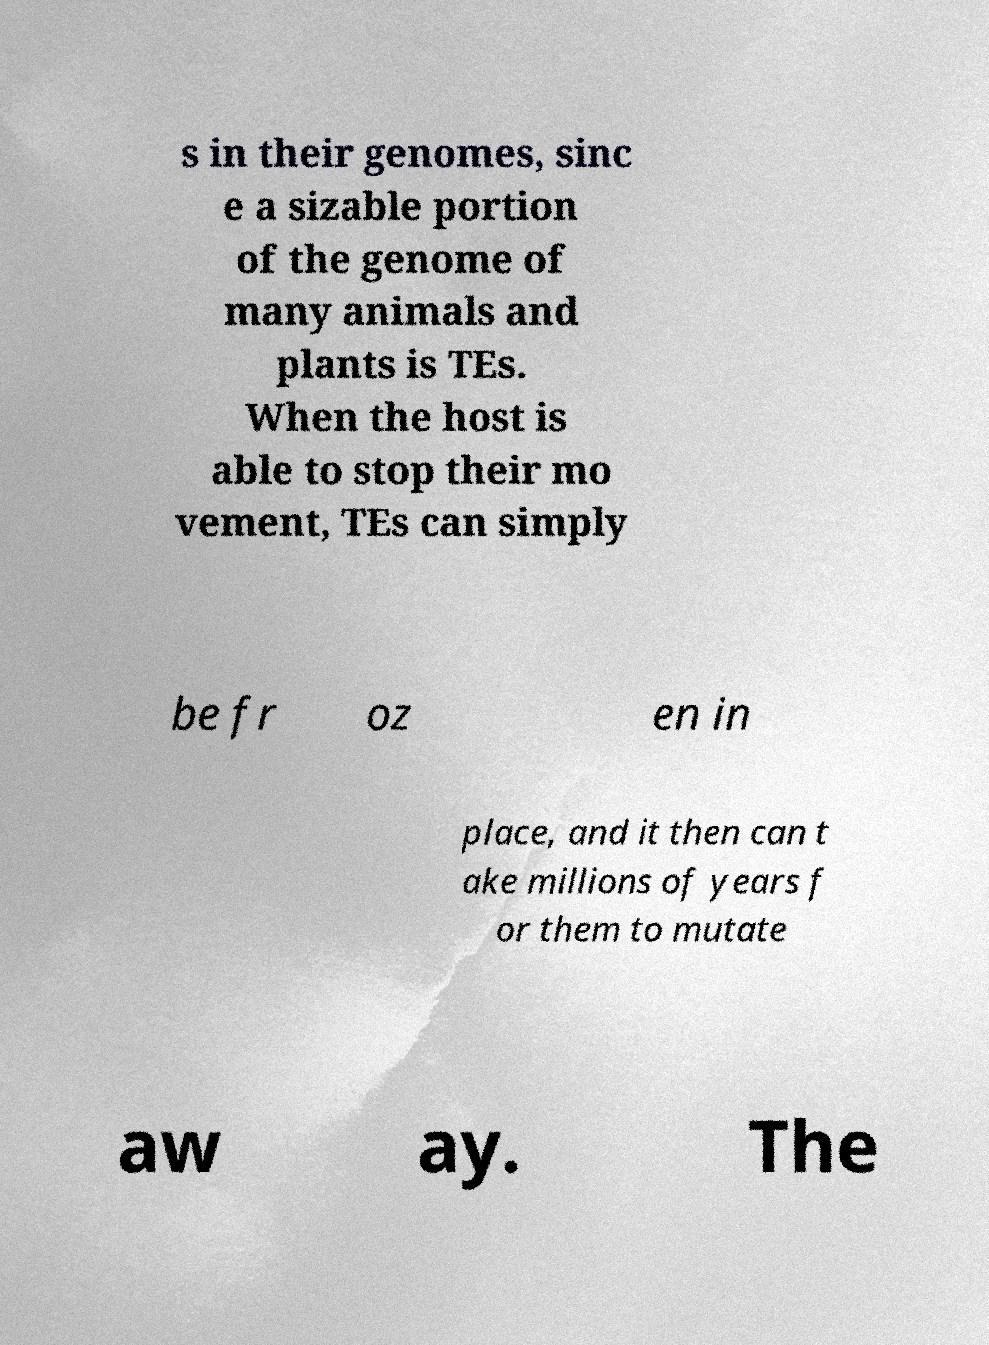What messages or text are displayed in this image? I need them in a readable, typed format. s in their genomes, sinc e a sizable portion of the genome of many animals and plants is TEs. When the host is able to stop their mo vement, TEs can simply be fr oz en in place, and it then can t ake millions of years f or them to mutate aw ay. The 